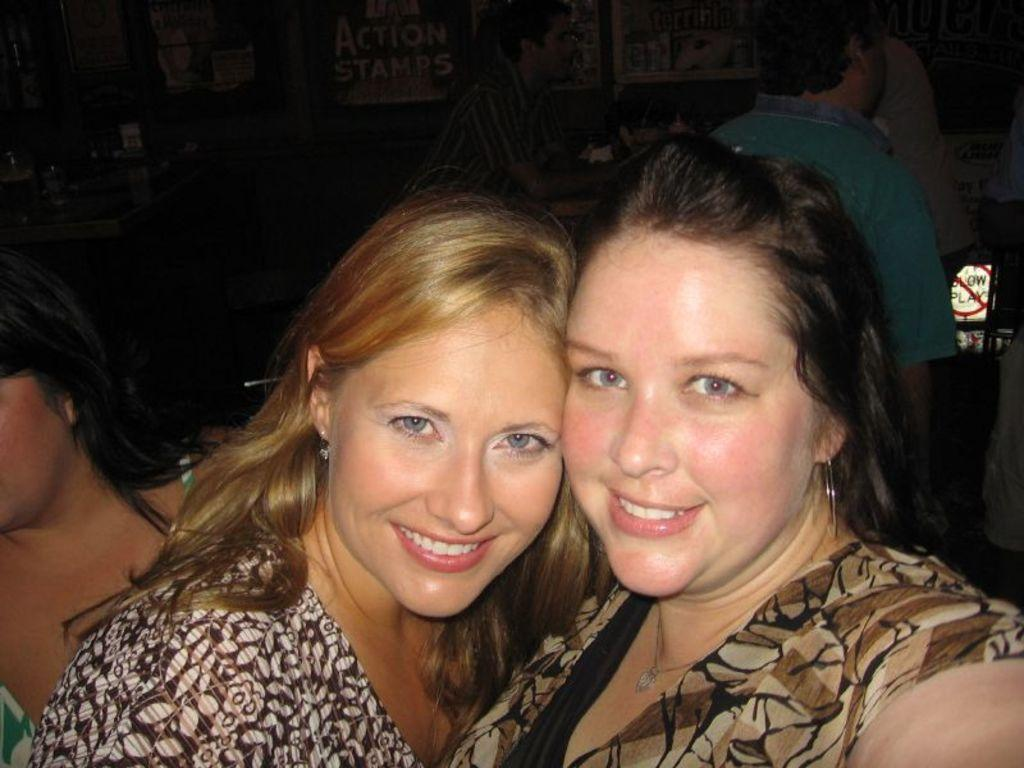What can be observed about the people in the image? There are people with different color dresses in the image. What is visible in the background of the image? There are boards in the background of the image. What can be seen on the boards? Something is written on the boards. Can you tell me how many horses are present in the image? There are no horses present in the image. What type of eggnog is being served at the event depicted in the image? There is no mention of eggnog or any event in the image. 